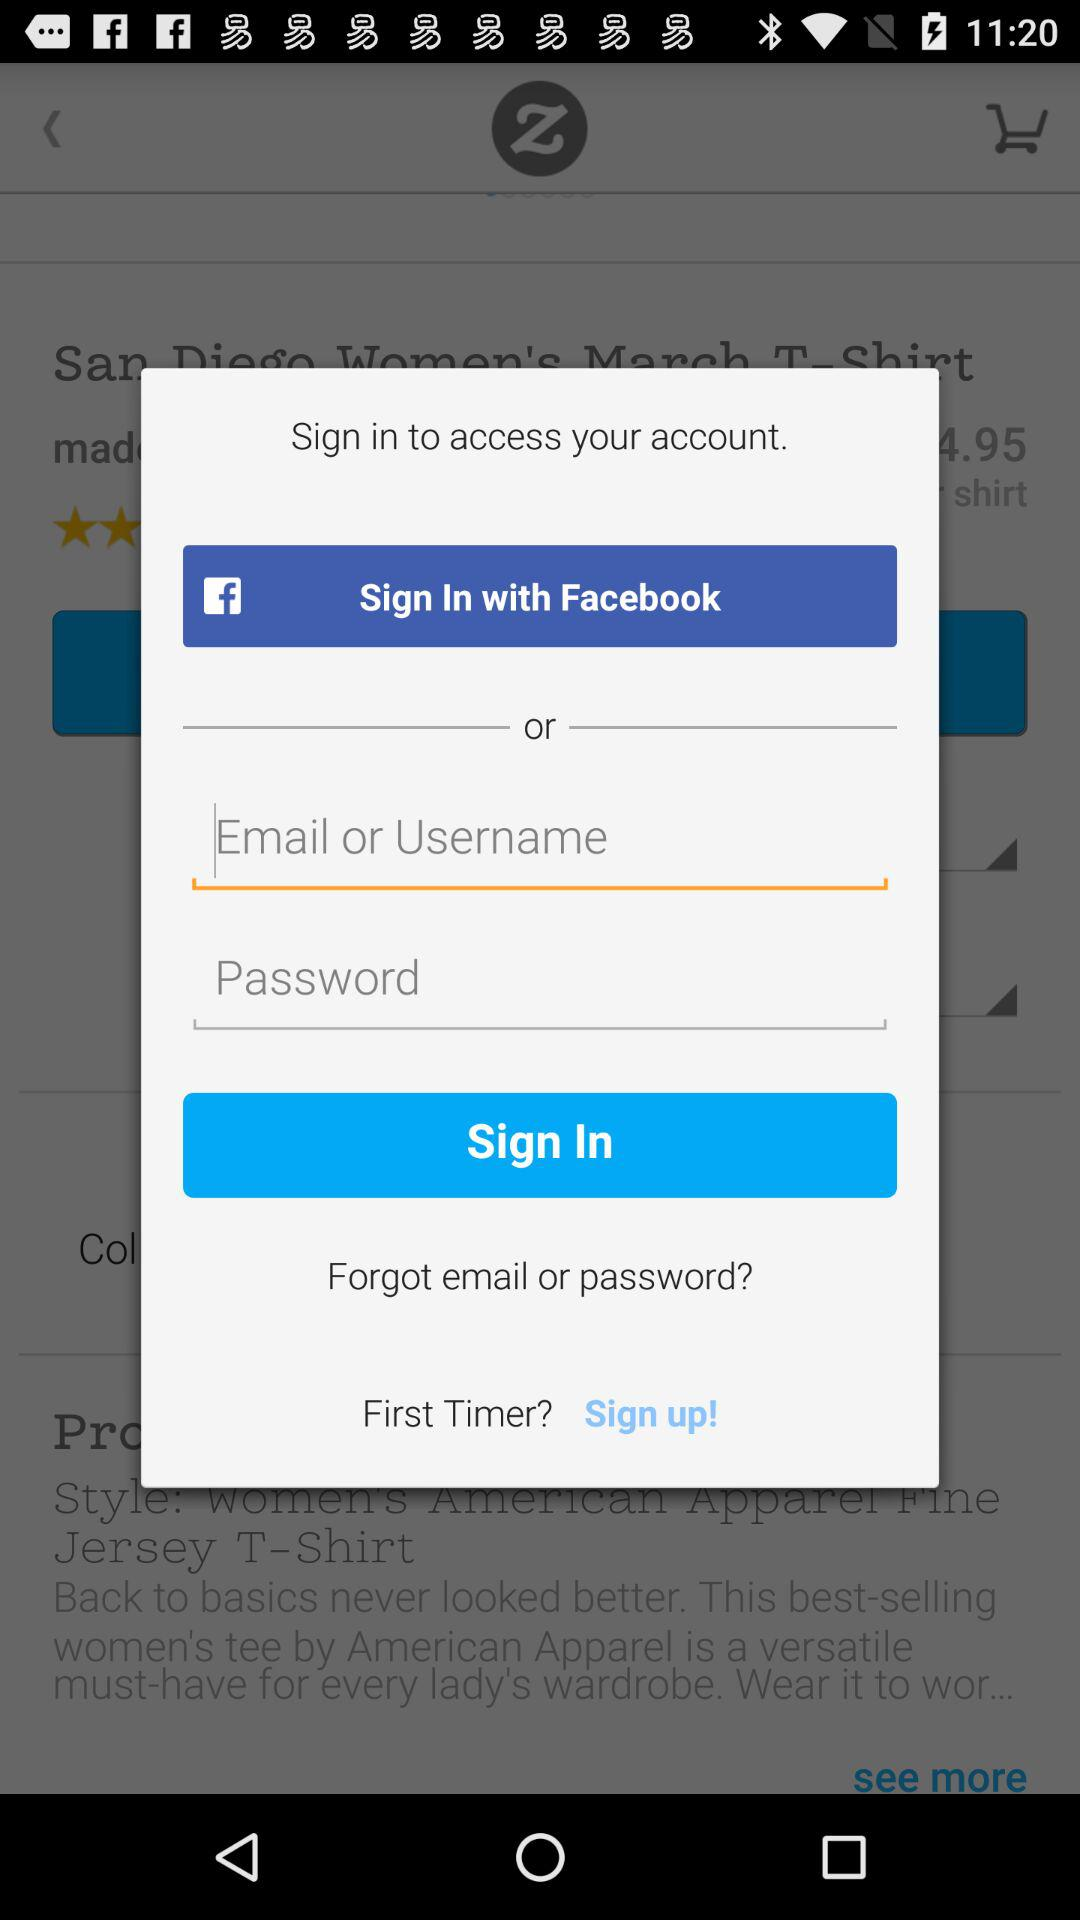What application can we sign in with? You can sign in with "Facebook". 